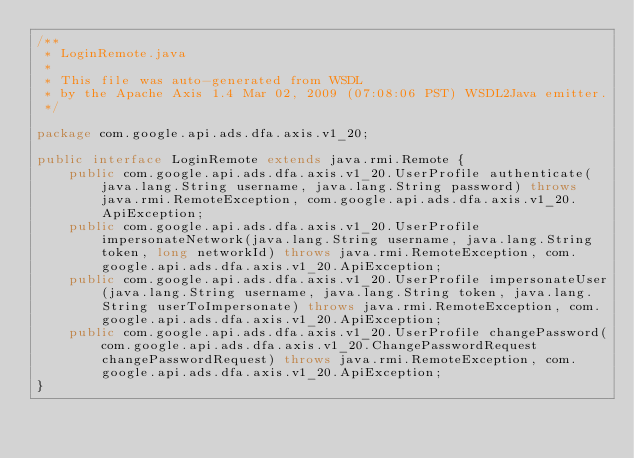Convert code to text. <code><loc_0><loc_0><loc_500><loc_500><_Java_>/**
 * LoginRemote.java
 *
 * This file was auto-generated from WSDL
 * by the Apache Axis 1.4 Mar 02, 2009 (07:08:06 PST) WSDL2Java emitter.
 */

package com.google.api.ads.dfa.axis.v1_20;

public interface LoginRemote extends java.rmi.Remote {
    public com.google.api.ads.dfa.axis.v1_20.UserProfile authenticate(java.lang.String username, java.lang.String password) throws java.rmi.RemoteException, com.google.api.ads.dfa.axis.v1_20.ApiException;
    public com.google.api.ads.dfa.axis.v1_20.UserProfile impersonateNetwork(java.lang.String username, java.lang.String token, long networkId) throws java.rmi.RemoteException, com.google.api.ads.dfa.axis.v1_20.ApiException;
    public com.google.api.ads.dfa.axis.v1_20.UserProfile impersonateUser(java.lang.String username, java.lang.String token, java.lang.String userToImpersonate) throws java.rmi.RemoteException, com.google.api.ads.dfa.axis.v1_20.ApiException;
    public com.google.api.ads.dfa.axis.v1_20.UserProfile changePassword(com.google.api.ads.dfa.axis.v1_20.ChangePasswordRequest changePasswordRequest) throws java.rmi.RemoteException, com.google.api.ads.dfa.axis.v1_20.ApiException;
}
</code> 